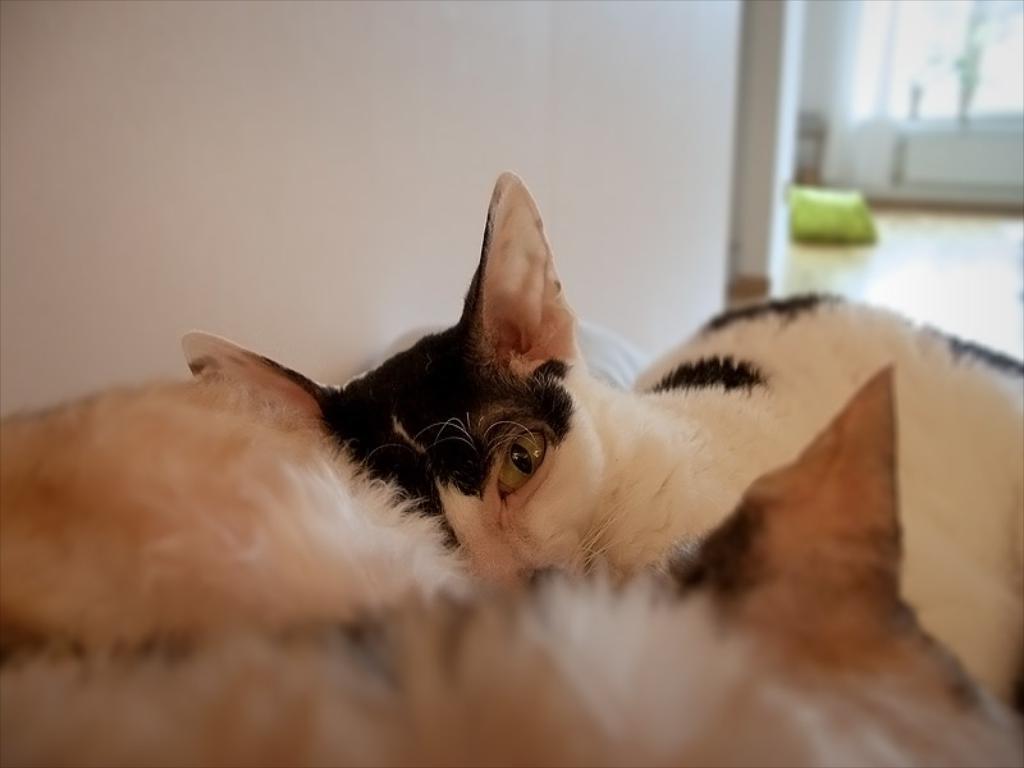Please provide a concise description of this image. In this picture there are cats which are in brown and white in color. On the top, there is a wall. 